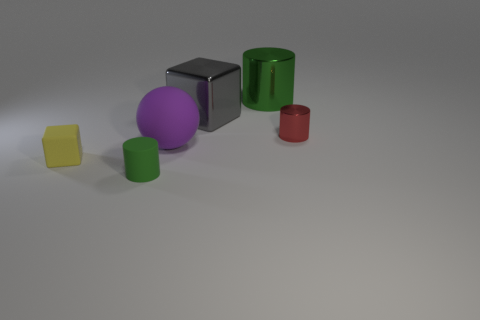Are there fewer matte balls in front of the small green cylinder than tiny green matte objects that are behind the yellow matte cube?
Keep it short and to the point. No. There is a matte cylinder; is it the same size as the cylinder behind the big gray metallic thing?
Give a very brief answer. No. There is a rubber thing that is behind the small green rubber object and in front of the large purple sphere; what shape is it?
Keep it short and to the point. Cube. There is a red thing that is made of the same material as the gray cube; what size is it?
Offer a very short reply. Small. There is a green rubber object that is in front of the big ball; how many small metallic cylinders are behind it?
Ensure brevity in your answer.  1. Are the green cylinder that is on the right side of the large purple ball and the purple ball made of the same material?
Offer a terse response. No. What is the size of the cube that is behind the tiny object on the right side of the large metal cube?
Give a very brief answer. Large. What is the size of the cylinder that is behind the metal cylinder in front of the object that is behind the large cube?
Provide a short and direct response. Large. There is a green thing that is behind the purple ball; is it the same shape as the tiny thing that is in front of the tiny yellow rubber object?
Keep it short and to the point. Yes. What number of other things are the same color as the small rubber cylinder?
Keep it short and to the point. 1. 